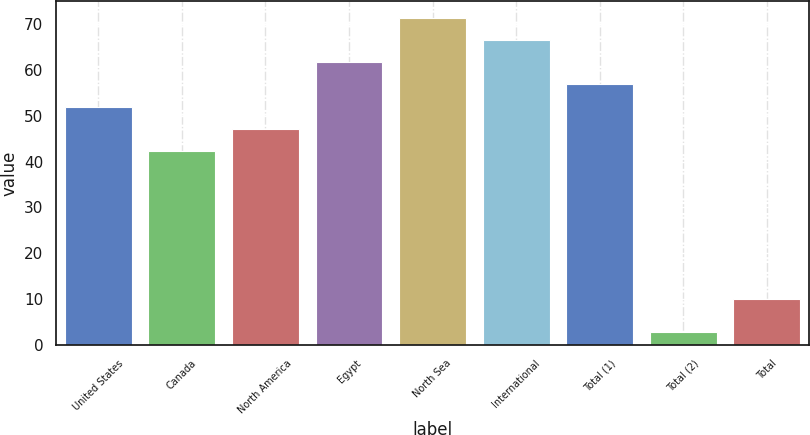<chart> <loc_0><loc_0><loc_500><loc_500><bar_chart><fcel>United States<fcel>Canada<fcel>North America<fcel>Egypt<fcel>North Sea<fcel>International<fcel>Total (1)<fcel>Total (2)<fcel>Total<nl><fcel>52.03<fcel>42.33<fcel>47.18<fcel>61.73<fcel>71.43<fcel>66.58<fcel>56.88<fcel>2.8<fcel>9.98<nl></chart> 